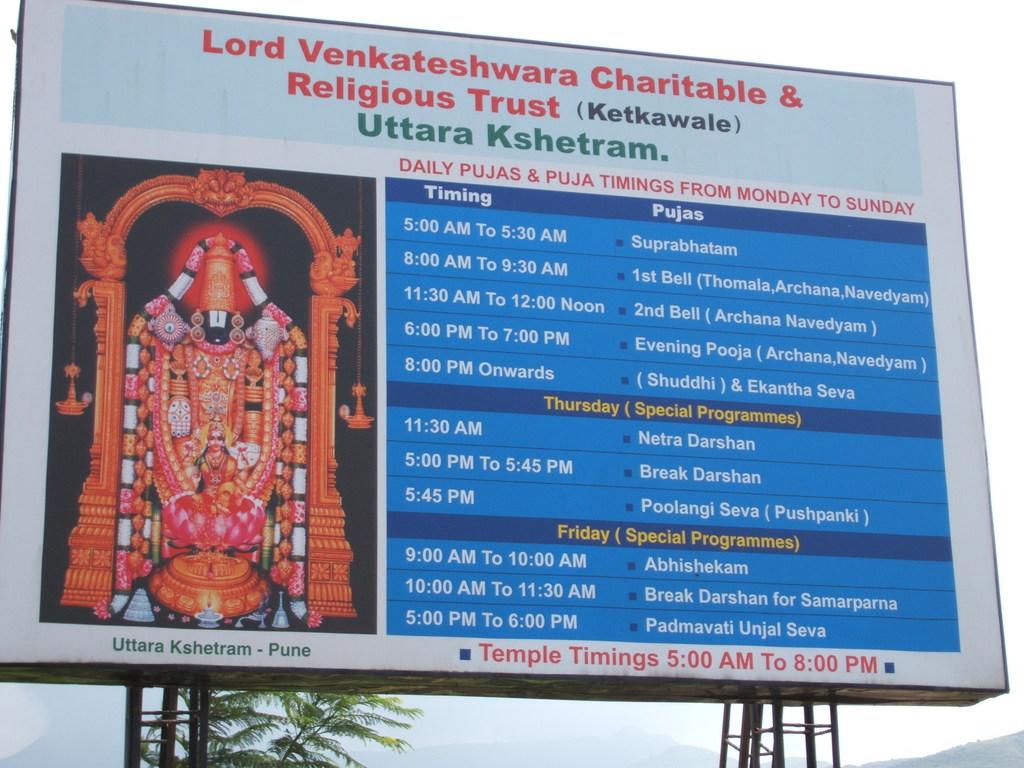Which foundation is opearing these events?
Offer a terse response. Lord venkateshwara charitable & religious trust. What are the hours of operation?
Offer a terse response. 5:00 am to 8:00 pm. 